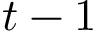<formula> <loc_0><loc_0><loc_500><loc_500>t - 1</formula> 